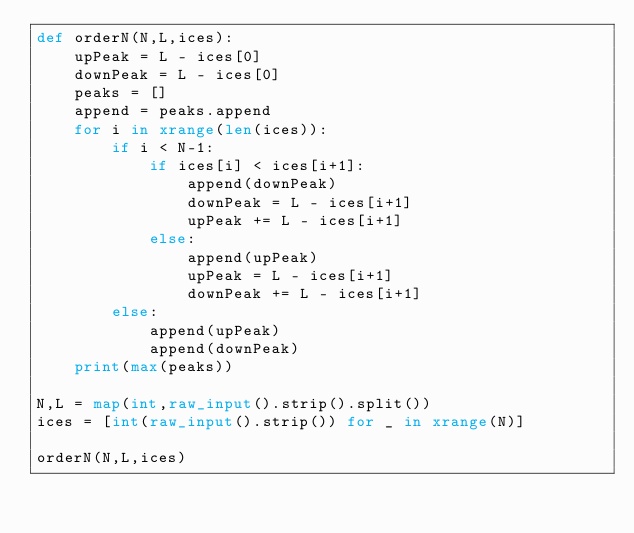<code> <loc_0><loc_0><loc_500><loc_500><_Python_>def orderN(N,L,ices):
    upPeak = L - ices[0]
    downPeak = L - ices[0]
    peaks = []
    append = peaks.append
    for i in xrange(len(ices)):
        if i < N-1:
            if ices[i] < ices[i+1]:
                append(downPeak)
                downPeak = L - ices[i+1]
                upPeak += L - ices[i+1]
            else:
                append(upPeak)
                upPeak = L - ices[i+1]
                downPeak += L - ices[i+1]
        else:
            append(upPeak)
            append(downPeak)
    print(max(peaks))

N,L = map(int,raw_input().strip().split())
ices = [int(raw_input().strip()) for _ in xrange(N)]

orderN(N,L,ices)</code> 